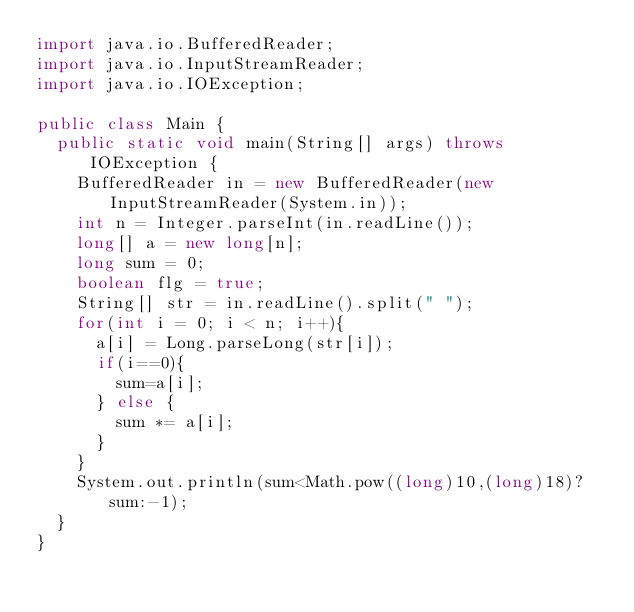Convert code to text. <code><loc_0><loc_0><loc_500><loc_500><_Java_>import java.io.BufferedReader;
import java.io.InputStreamReader;
import java.io.IOException;

public class Main {
  public static void main(String[] args) throws IOException {
    BufferedReader in = new BufferedReader(new InputStreamReader(System.in));
    int n = Integer.parseInt(in.readLine());
    long[] a = new long[n];
    long sum = 0;
    boolean flg = true;
    String[] str = in.readLine().split(" ");
    for(int i = 0; i < n; i++){
      a[i] = Long.parseLong(str[i]);
      if(i==0){
        sum=a[i];
      } else {
        sum *= a[i];
      }
    }
    System.out.println(sum<Math.pow((long)10,(long)18)?sum:-1);
  }
}</code> 